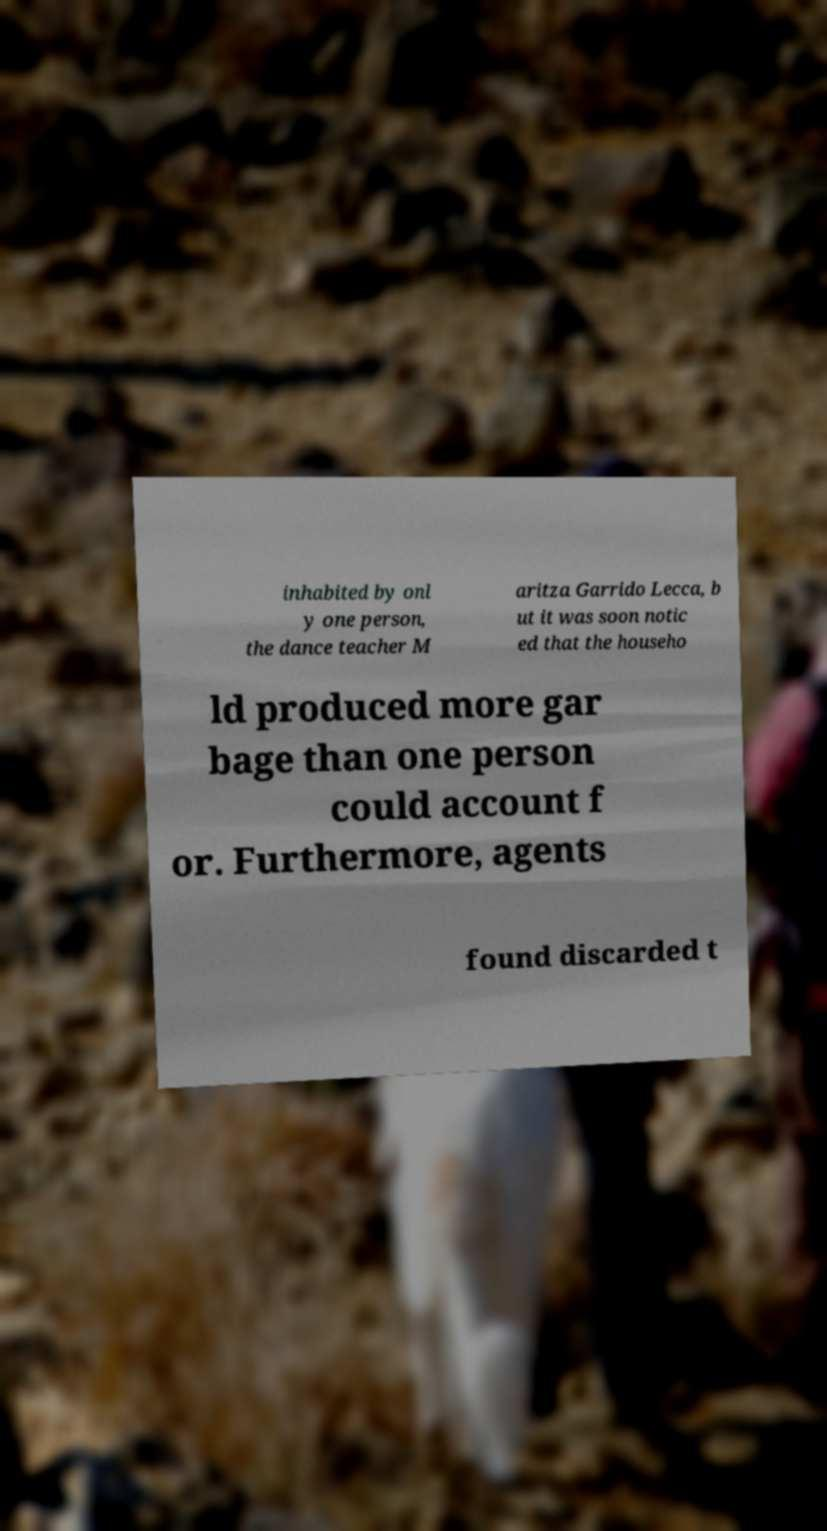I need the written content from this picture converted into text. Can you do that? inhabited by onl y one person, the dance teacher M aritza Garrido Lecca, b ut it was soon notic ed that the househo ld produced more gar bage than one person could account f or. Furthermore, agents found discarded t 